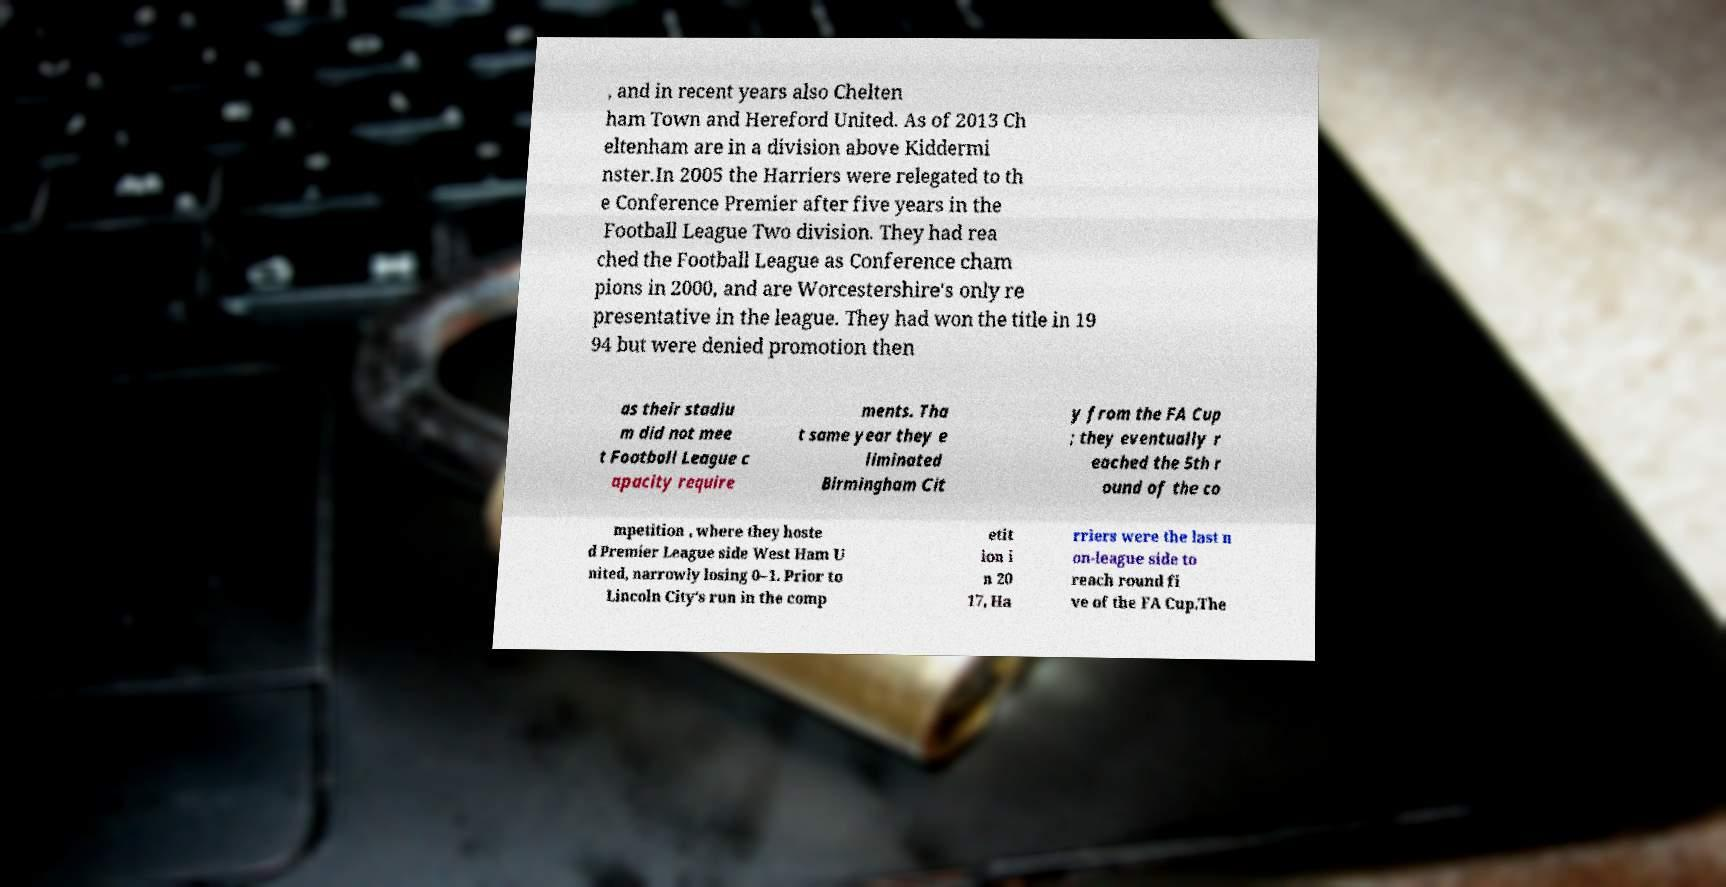Could you extract and type out the text from this image? , and in recent years also Chelten ham Town and Hereford United. As of 2013 Ch eltenham are in a division above Kiddermi nster.In 2005 the Harriers were relegated to th e Conference Premier after five years in the Football League Two division. They had rea ched the Football League as Conference cham pions in 2000, and are Worcestershire's only re presentative in the league. They had won the title in 19 94 but were denied promotion then as their stadiu m did not mee t Football League c apacity require ments. Tha t same year they e liminated Birmingham Cit y from the FA Cup ; they eventually r eached the 5th r ound of the co mpetition , where they hoste d Premier League side West Ham U nited, narrowly losing 0–1. Prior to Lincoln City's run in the comp etit ion i n 20 17, Ha rriers were the last n on-league side to reach round fi ve of the FA Cup.The 